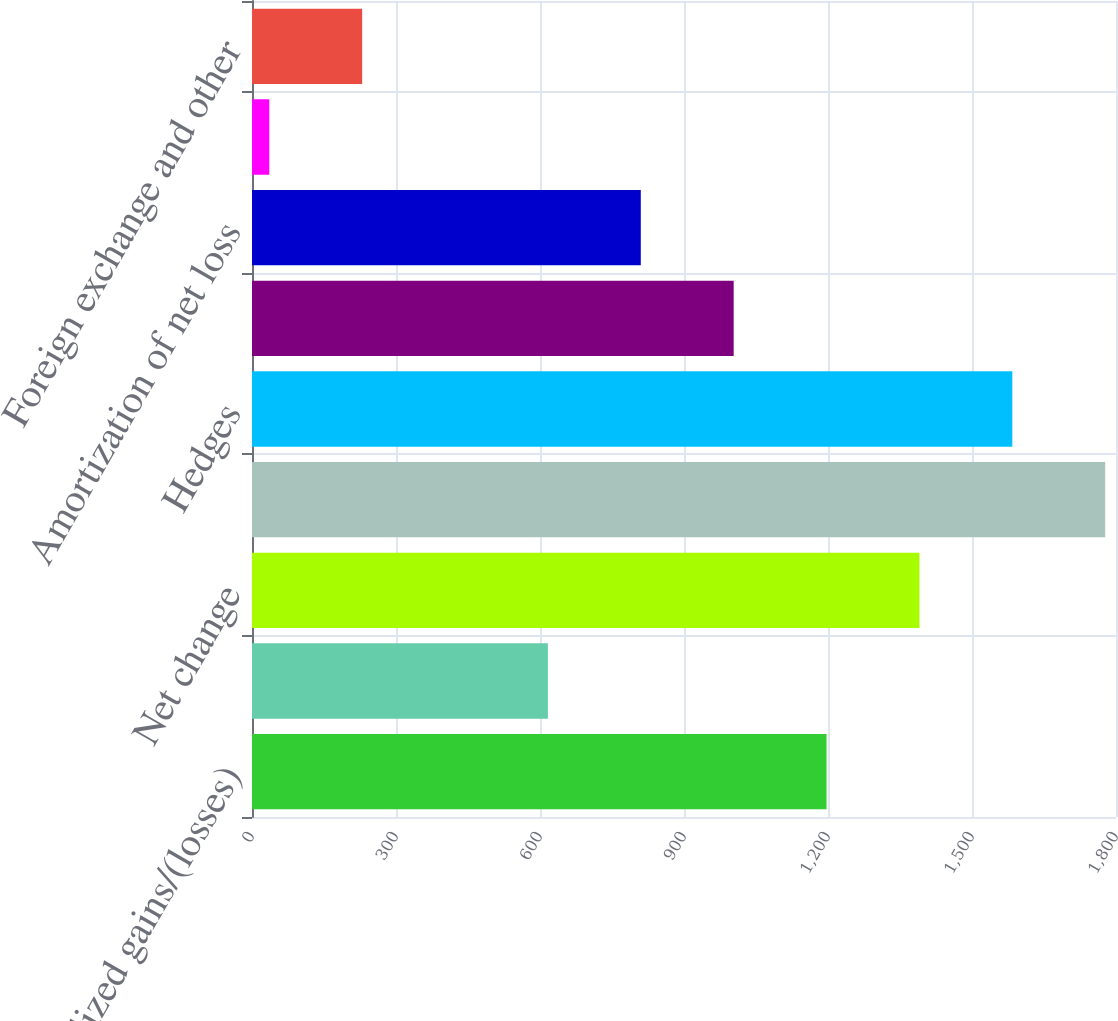Convert chart to OTSL. <chart><loc_0><loc_0><loc_500><loc_500><bar_chart><fcel>Net unrealized gains/(losses)<fcel>Reclassification adjustment<fcel>Net change<fcel>Translation<fcel>Hedges<fcel>Net gains/(losses) arising<fcel>Amortization of net loss<fcel>Prior service costs/(credits)<fcel>Foreign exchange and other<nl><fcel>1197<fcel>616.5<fcel>1390.5<fcel>1777.5<fcel>1584<fcel>1003.5<fcel>810<fcel>36<fcel>229.5<nl></chart> 